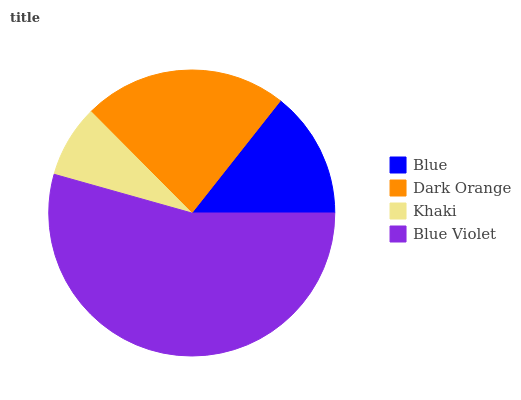Is Khaki the minimum?
Answer yes or no. Yes. Is Blue Violet the maximum?
Answer yes or no. Yes. Is Dark Orange the minimum?
Answer yes or no. No. Is Dark Orange the maximum?
Answer yes or no. No. Is Dark Orange greater than Blue?
Answer yes or no. Yes. Is Blue less than Dark Orange?
Answer yes or no. Yes. Is Blue greater than Dark Orange?
Answer yes or no. No. Is Dark Orange less than Blue?
Answer yes or no. No. Is Dark Orange the high median?
Answer yes or no. Yes. Is Blue the low median?
Answer yes or no. Yes. Is Blue the high median?
Answer yes or no. No. Is Dark Orange the low median?
Answer yes or no. No. 